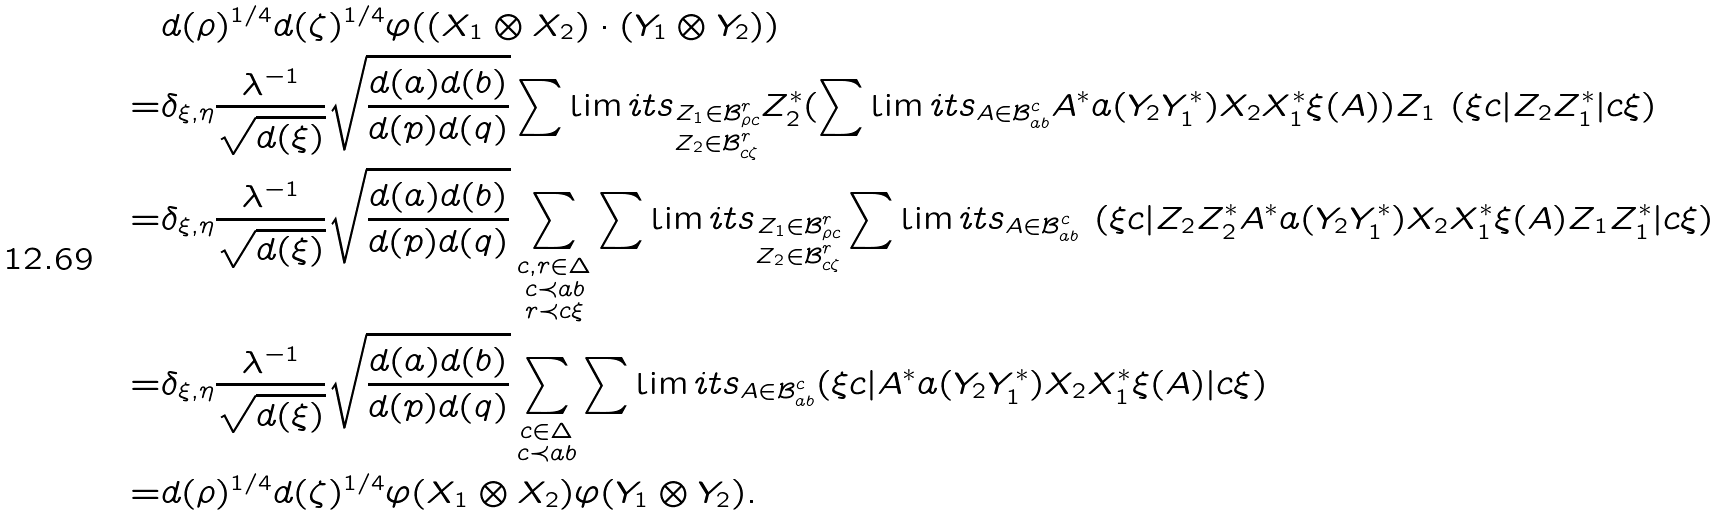<formula> <loc_0><loc_0><loc_500><loc_500>& d ( \rho ) ^ { 1 / 4 } d ( \zeta ) ^ { 1 / 4 } \varphi ( ( X _ { 1 } \otimes X _ { 2 } ) \cdot ( Y _ { 1 } \otimes Y _ { 2 } ) ) \\ = & \delta _ { \xi , \eta } \frac { \lambda ^ { - 1 } } { \sqrt { d ( \xi ) } } \sqrt { \frac { d ( a ) d ( b ) } { d ( p ) d ( q ) } } \sum \lim i t s _ { \substack { Z _ { 1 } \in \mathcal { B } _ { \rho c } ^ { r } \\ Z _ { 2 } \in \mathcal { B } _ { c \zeta } ^ { r } } } Z _ { 2 } ^ { \ast } ( \sum \lim i t s _ { A \in \mathcal { B } _ { a b } ^ { c } } A ^ { \ast } a ( Y _ { 2 } Y _ { 1 } ^ { \ast } ) X _ { 2 } X _ { 1 } ^ { \ast } \xi ( A ) ) Z _ { 1 } \ ( \xi c | Z _ { 2 } Z _ { 1 } ^ { \ast } | c \xi ) \\ = & \delta _ { \xi , \eta } \frac { \lambda ^ { - 1 } } { \sqrt { d ( \xi ) } } \sqrt { \frac { d ( a ) d ( b ) } { d ( p ) d ( q ) } } \sum _ { \substack { c , r \in \Delta \\ c \prec a b \\ r \prec c \xi } } \sum \lim i t s _ { \substack { Z _ { 1 } \in \mathcal { B } _ { \rho c } ^ { r } \\ Z _ { 2 } \in \mathcal { B } _ { c \zeta } ^ { r } } } \sum \lim i t s _ { A \in \mathcal { B } _ { a b } ^ { c } } \ ( \xi c | Z _ { 2 } Z _ { 2 } ^ { \ast } A ^ { \ast } a ( Y _ { 2 } Y _ { 1 } ^ { \ast } ) X _ { 2 } X _ { 1 } ^ { \ast } \xi ( A ) Z _ { 1 } Z _ { 1 } ^ { \ast } | c \xi ) \\ = & \delta _ { \xi , \eta } \frac { \lambda ^ { - 1 } } { \sqrt { d ( \xi ) } } \sqrt { \frac { d ( a ) d ( b ) } { d ( p ) d ( q ) } } \sum _ { \substack { c \in \Delta \\ c \prec a b } } \sum \lim i t s _ { A \in \mathcal { B } _ { a b } ^ { c } } ( \xi c | A ^ { \ast } a ( Y _ { 2 } Y _ { 1 } ^ { \ast } ) X _ { 2 } X _ { 1 } ^ { \ast } \xi ( A ) | c \xi ) \\ = & d ( \rho ) ^ { 1 / 4 } d ( \zeta ) ^ { 1 / 4 } \varphi ( X _ { 1 } \otimes X _ { 2 } ) \varphi ( Y _ { 1 } \otimes Y _ { 2 } ) .</formula> 